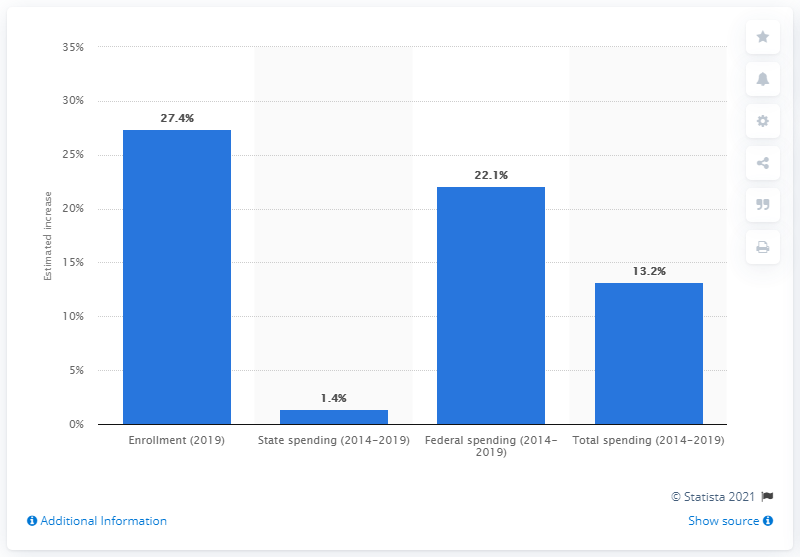Draw attention to some important aspects in this diagram. According to projections, Medicaid spending is expected to increase by 13.2% between 2014 and 2019. By 2019, it is estimated that there will be an increase of 27.4% in Medicaid enrollment. 